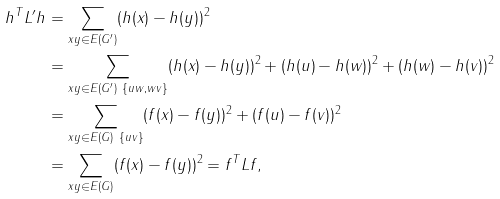<formula> <loc_0><loc_0><loc_500><loc_500>h ^ { T } L ^ { \prime } h & = \sum _ { x y \in E ( G ^ { \prime } ) } ( h ( x ) - h ( y ) ) ^ { 2 } \\ & = \sum _ { x y \in E ( G ^ { \prime } ) \ \{ u w , w v \} } ( h ( x ) - h ( y ) ) ^ { 2 } + ( h ( u ) - h ( w ) ) ^ { 2 } + ( h ( w ) - h ( v ) ) ^ { 2 } \\ & = \sum _ { x y \in E ( G ) \ \{ u v \} } ( f ( x ) - f ( y ) ) ^ { 2 } + ( f ( u ) - f ( v ) ) ^ { 2 } \\ & = \sum _ { x y \in E ( G ) } ( f ( x ) - f ( y ) ) ^ { 2 } = f ^ { T } L f ,</formula> 